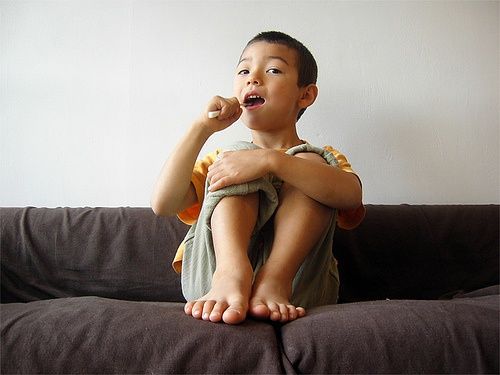Describe the objects in this image and their specific colors. I can see couch in lightgray, black, and gray tones, people in lightgray, black, brown, and maroon tones, and toothbrush in lightgray, ivory, tan, maroon, and brown tones in this image. 